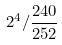<formula> <loc_0><loc_0><loc_500><loc_500>2 ^ { 4 } / \frac { 2 4 0 } { 2 5 2 }</formula> 